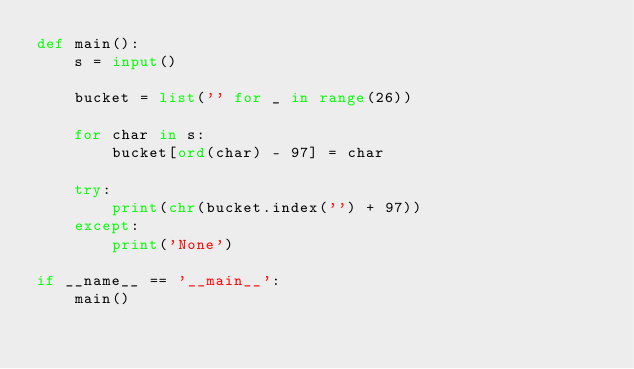Convert code to text. <code><loc_0><loc_0><loc_500><loc_500><_Python_>def main():
    s = input()

    bucket = list('' for _ in range(26))

    for char in s:
        bucket[ord(char) - 97] = char
    
    try:
        print(chr(bucket.index('') + 97))
    except:
        print('None')

if __name__ == '__main__':
    main()</code> 